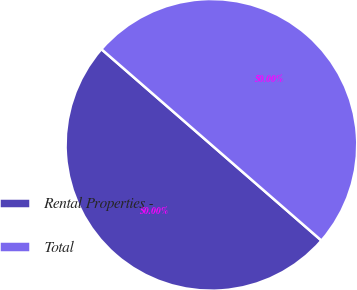<chart> <loc_0><loc_0><loc_500><loc_500><pie_chart><fcel>Rental Properties -<fcel>Total<nl><fcel>50.0%<fcel>50.0%<nl></chart> 